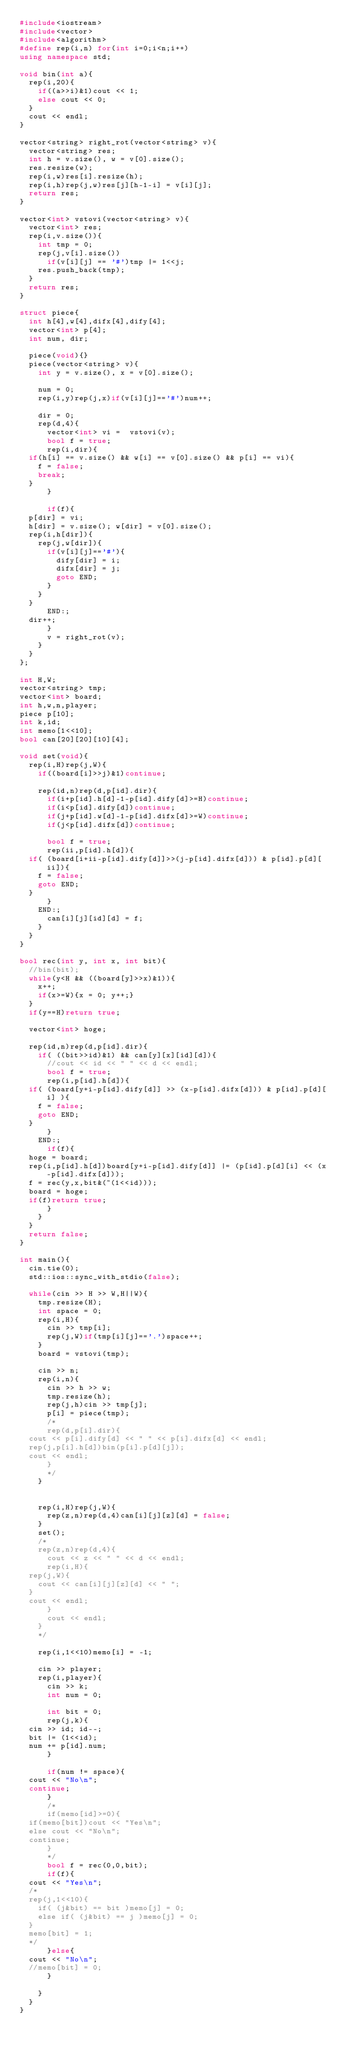<code> <loc_0><loc_0><loc_500><loc_500><_C++_>#include<iostream>
#include<vector>
#include<algorithm>
#define rep(i,n) for(int i=0;i<n;i++)
using namespace std;

void bin(int a){
  rep(i,20){
    if((a>>i)&1)cout << 1;
    else cout << 0;
  }
  cout << endl;
}

vector<string> right_rot(vector<string> v){
  vector<string> res;
  int h = v.size(), w = v[0].size();
  res.resize(w);
  rep(i,w)res[i].resize(h);
  rep(i,h)rep(j,w)res[j][h-1-i] = v[i][j];
  return res;
}

vector<int> vstovi(vector<string> v){
  vector<int> res;
  rep(i,v.size()){
    int tmp = 0;
    rep(j,v[i].size())
      if(v[i][j] == '#')tmp |= 1<<j;
    res.push_back(tmp);
  }
  return res;
}

struct piece{
  int h[4],w[4],difx[4],dify[4];
  vector<int> p[4];
  int num, dir;
  
  piece(void){}
  piece(vector<string> v){
    int y = v.size(), x = v[0].size();
    
    num = 0;
    rep(i,y)rep(j,x)if(v[i][j]=='#')num++;
    
    dir = 0;
    rep(d,4){
      vector<int> vi =  vstovi(v);
      bool f = true;
      rep(i,dir){
	if(h[i] == v.size() && w[i] == v[0].size() && p[i] == vi){
	  f = false;
	  break;
	}
      }
      
      if(f){
	p[dir] = vi;
	h[dir] = v.size(); w[dir] = v[0].size();
	rep(i,h[dir]){
	  rep(j,w[dir]){
	    if(v[i][j]=='#'){
	      dify[dir] = i;
	      difx[dir] = j;
	      goto END;
	    }
	  }
	}
      END:;
	dir++;
      }
      v = right_rot(v);
    }
  }
};

int H,W;
vector<string> tmp;
vector<int> board;
int h,w,n,player;
piece p[10];
int k,id;
int memo[1<<10];
bool can[20][20][10][4];

void set(void){
  rep(i,H)rep(j,W){
    if((board[i]>>j)&1)continue;

    rep(id,n)rep(d,p[id].dir){
      if(i+p[id].h[d]-1-p[id].dify[d]>=H)continue;
      if(i<p[id].dify[d])continue;
      if(j+p[id].w[d]-1-p[id].difx[d]>=W)continue;
      if(j<p[id].difx[d])continue;

      bool f = true;
      rep(ii,p[id].h[d]){
	if( (board[i+ii-p[id].dify[d]]>>(j-p[id].difx[d])) & p[id].p[d][ii]){
	  f = false;
	  goto END;
	}
      }
    END:;
      can[i][j][id][d] = f;
    }
  }
}

bool rec(int y, int x, int bit){
  //bin(bit);
  while(y<H && ((board[y]>>x)&1)){
    x++;
    if(x>=W){x = 0; y++;}
  }
  if(y==H)return true;

  vector<int> hoge;

  rep(id,n)rep(d,p[id].dir){
    if( ((bit>>id)&1) && can[y][x][id][d]){
      //cout << id << " " << d << endl;
      bool f = true;
      rep(i,p[id].h[d]){
	if( (board[y+i-p[id].dify[d]] >> (x-p[id].difx[d])) & p[id].p[d][i] ){
	  f = false;
	  goto END;
	}
      }
    END:;
      if(f){
	hoge = board;
	rep(i,p[id].h[d])board[y+i-p[id].dify[d]] |= (p[id].p[d][i] << (x-p[id].difx[d]));
	f = rec(y,x,bit&(~(1<<id)));
	board = hoge;
	if(f)return true;
      }
    }
  }
  return false;
}

int main(){
  cin.tie(0);
  std::ios::sync_with_stdio(false);

  while(cin >> H >> W,H||W){
    tmp.resize(H);
    int space = 0;
    rep(i,H){
      cin >> tmp[i];
      rep(j,W)if(tmp[i][j]=='.')space++;
    }
    board = vstovi(tmp);

    cin >> n;
    rep(i,n){
      cin >> h >> w;
      tmp.resize(h);
      rep(j,h)cin >> tmp[j];
      p[i] = piece(tmp);
      /*
      rep(d,p[i].dir){
	cout << p[i].dify[d] << " " << p[i].difx[d] << endl;
	rep(j,p[i].h[d])bin(p[i].p[d][j]);
	cout << endl;
      }
      */
    }


    rep(i,H)rep(j,W){
      rep(z,n)rep(d,4)can[i][j][z][d] = false;
    }
    set();
    /*
    rep(z,n)rep(d,4){
      cout << z << " " << d << endl;
      rep(i,H){
	rep(j,W){
	  cout << can[i][j][z][d] << " ";
	}
	cout << endl;
      }
      cout << endl;
    }
    */

    rep(i,1<<10)memo[i] = -1;

    cin >> player;
    rep(i,player){
      cin >> k;
      int num = 0;
      
      int bit = 0;
      rep(j,k){
	cin >> id; id--;
	bit |= (1<<id);
	num += p[id].num;
      }
      
      if(num != space){
	cout << "No\n";
	continue;
      }
      /*
      if(memo[id]>=0){
	if(memo[bit])cout << "Yes\n";
	else cout << "No\n";
	continue;
      }
      */
      bool f = rec(0,0,bit);
      if(f){
	cout << "Yes\n";
	/*
	rep(j,1<<10){
	  if( (j&bit) == bit )memo[j] = 0;
	  else if( (j&bit) == j )memo[j] = 0;
	}
	memo[bit] = 1;
	*/
      }else{
	cout << "No\n";
	//memo[bit] = 0;
      }
      
    }
  }
}</code> 